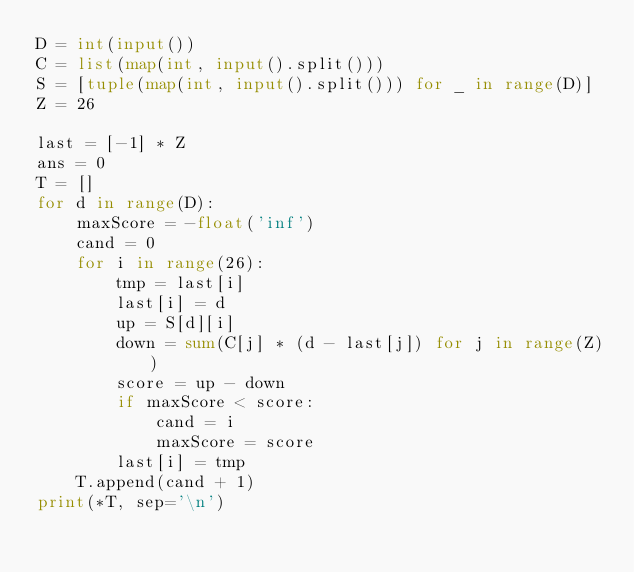Convert code to text. <code><loc_0><loc_0><loc_500><loc_500><_Python_>D = int(input())
C = list(map(int, input().split()))
S = [tuple(map(int, input().split())) for _ in range(D)]
Z = 26

last = [-1] * Z
ans = 0
T = []
for d in range(D):
    maxScore = -float('inf')
    cand = 0
    for i in range(26):
        tmp = last[i]
        last[i] = d
        up = S[d][i]
        down = sum(C[j] * (d - last[j]) for j in range(Z))
        score = up - down
        if maxScore < score:
            cand = i
            maxScore = score
        last[i] = tmp
    T.append(cand + 1)
print(*T, sep='\n')
</code> 